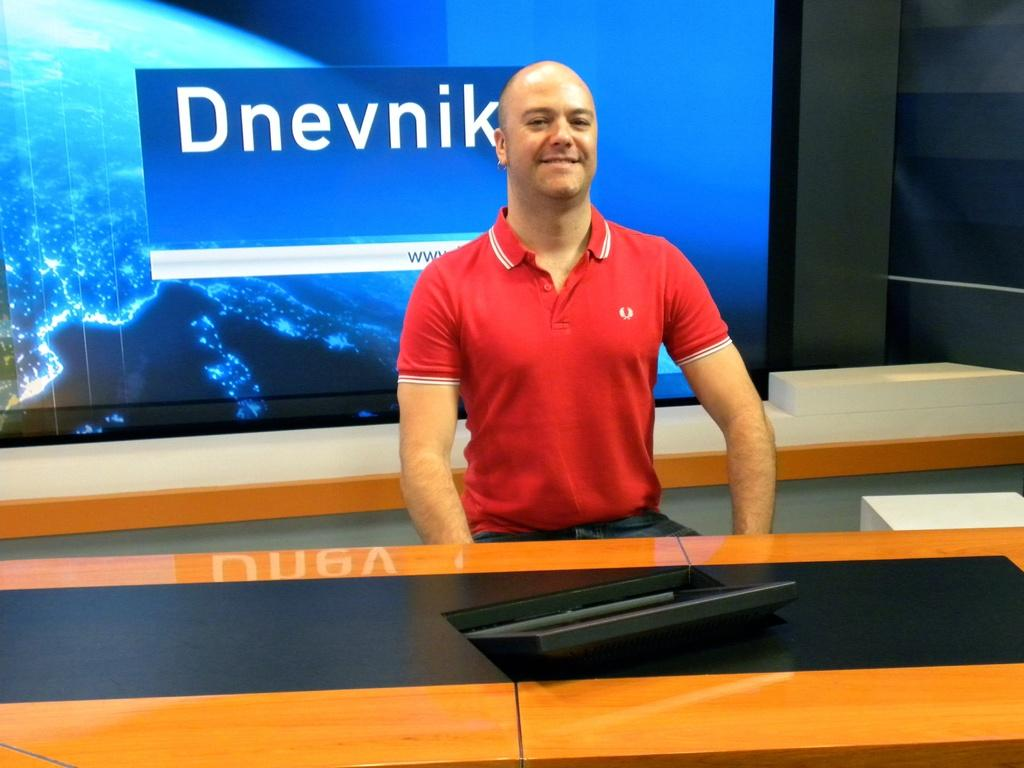<image>
Offer a succinct explanation of the picture presented. A bald, fit man sits as a representative of "Dnevik" at a display featuring their sign. 